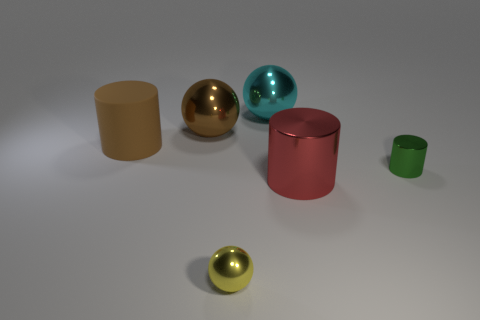Subtract all large brown spheres. How many spheres are left? 2 Add 4 objects. How many objects exist? 10 Subtract 1 cylinders. How many cylinders are left? 2 Add 4 big brown cylinders. How many big brown cylinders are left? 5 Add 3 green cylinders. How many green cylinders exist? 4 Subtract 0 purple cylinders. How many objects are left? 6 Subtract all small red metallic cubes. Subtract all brown spheres. How many objects are left? 5 